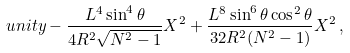Convert formula to latex. <formula><loc_0><loc_0><loc_500><loc_500>\ u n i t y - \frac { L ^ { 4 } \sin ^ { 4 } { \theta } } { 4 R ^ { 2 } \sqrt { N ^ { 2 } - 1 } } X ^ { 2 } + \frac { L ^ { 8 } \sin ^ { 6 } { \theta } \cos ^ { 2 } { \theta } } { 3 2 R ^ { 2 } ( N ^ { 2 } - 1 ) } X ^ { 2 } \, ,</formula> 